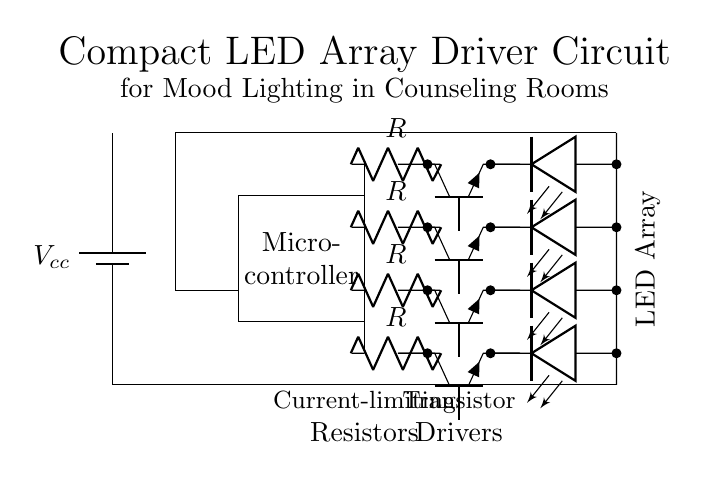What is the type of components used to drive the LEDs? The circuit uses transistors to drive the LEDs, indicated by the 'Tnpn' symbols in the diagram. Each transistor is connected to one LED, controlling its on/off state.
Answer: Transistors How many LEDs are included in the array? There are a total of four LEDs shown in the circuit diagram, as represented by the four corresponding 'led' symbols aligned vertically.
Answer: Four What is the purpose of the resistors in this circuit? The resistors are used to limit the current flowing through the LEDs, preventing them from drawing too much current and potentially burning out. Their position in series with each LED signifies this role.
Answer: Current limiting What type of microcontroller is used in this circuit? The specifics of the microcontroller model are not indicated in the diagram, only that there is a rectangle labeled 'Microcontroller' suggesting its presence as a control unit.
Answer: Microcontroller How are the LEDs and microcontroller connected? The LEDs are connected through transistors that are controlled by the microcontroller, with wires showing connections leading from the microcontroller to the transistors and subsequently to the LEDs.
Answer: Through transistors What is the supply voltage for this circuit? The circuit diagram shows a battery labeled 'Vcc', indicating the supply voltage. However, no specific voltage value is provided in the diagram itself.
Answer: Vcc (unspecified voltage) What is the purpose of the title in the circuit diagram? The title describes the overall function of the circuit, indicating that it is designed for mood lighting specifically suited for counseling rooms. This context helps understand its intended application.
Answer: Mood lighting 